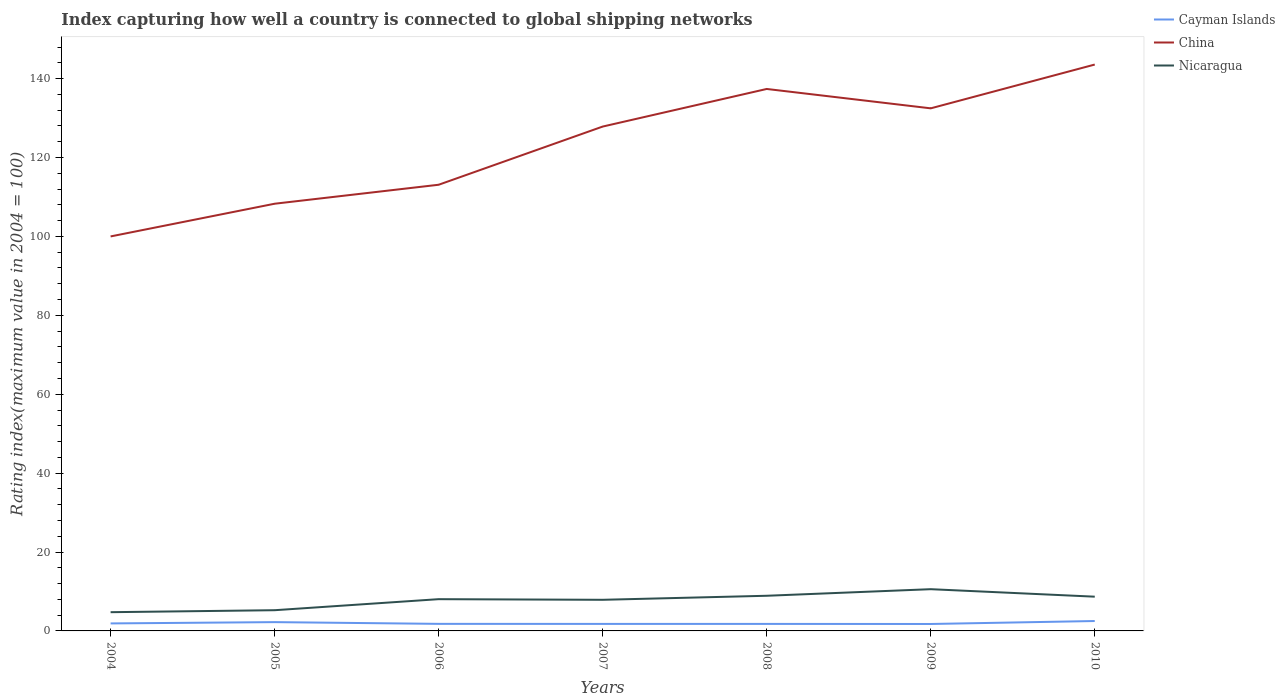Across all years, what is the maximum rating index in Nicaragua?
Keep it short and to the point. 4.75. In which year was the rating index in Nicaragua maximum?
Offer a terse response. 2004. What is the total rating index in China in the graph?
Your answer should be compact. -43.57. What is the difference between the highest and the second highest rating index in Cayman Islands?
Your answer should be very brief. 0.75. What is the difference between the highest and the lowest rating index in Cayman Islands?
Keep it short and to the point. 2. Is the rating index in Cayman Islands strictly greater than the rating index in China over the years?
Ensure brevity in your answer.  Yes. How many years are there in the graph?
Ensure brevity in your answer.  7. Are the values on the major ticks of Y-axis written in scientific E-notation?
Ensure brevity in your answer.  No. Does the graph contain any zero values?
Provide a short and direct response. No. Does the graph contain grids?
Provide a succinct answer. No. How are the legend labels stacked?
Offer a terse response. Vertical. What is the title of the graph?
Your answer should be very brief. Index capturing how well a country is connected to global shipping networks. Does "Solomon Islands" appear as one of the legend labels in the graph?
Your response must be concise. No. What is the label or title of the X-axis?
Your response must be concise. Years. What is the label or title of the Y-axis?
Offer a terse response. Rating index(maximum value in 2004 = 100). What is the Rating index(maximum value in 2004 = 100) in Cayman Islands in 2004?
Ensure brevity in your answer.  1.9. What is the Rating index(maximum value in 2004 = 100) in Nicaragua in 2004?
Your response must be concise. 4.75. What is the Rating index(maximum value in 2004 = 100) in Cayman Islands in 2005?
Provide a succinct answer. 2.23. What is the Rating index(maximum value in 2004 = 100) in China in 2005?
Offer a very short reply. 108.29. What is the Rating index(maximum value in 2004 = 100) in Nicaragua in 2005?
Provide a short and direct response. 5.25. What is the Rating index(maximum value in 2004 = 100) of Cayman Islands in 2006?
Provide a succinct answer. 1.79. What is the Rating index(maximum value in 2004 = 100) in China in 2006?
Ensure brevity in your answer.  113.1. What is the Rating index(maximum value in 2004 = 100) of Nicaragua in 2006?
Your answer should be very brief. 8.05. What is the Rating index(maximum value in 2004 = 100) of Cayman Islands in 2007?
Your response must be concise. 1.78. What is the Rating index(maximum value in 2004 = 100) in China in 2007?
Give a very brief answer. 127.85. What is the Rating index(maximum value in 2004 = 100) in Nicaragua in 2007?
Provide a succinct answer. 7.89. What is the Rating index(maximum value in 2004 = 100) of Cayman Islands in 2008?
Your response must be concise. 1.78. What is the Rating index(maximum value in 2004 = 100) of China in 2008?
Provide a succinct answer. 137.38. What is the Rating index(maximum value in 2004 = 100) of Nicaragua in 2008?
Offer a very short reply. 8.91. What is the Rating index(maximum value in 2004 = 100) of Cayman Islands in 2009?
Keep it short and to the point. 1.76. What is the Rating index(maximum value in 2004 = 100) of China in 2009?
Keep it short and to the point. 132.47. What is the Rating index(maximum value in 2004 = 100) in Nicaragua in 2009?
Provide a succinct answer. 10.58. What is the Rating index(maximum value in 2004 = 100) in Cayman Islands in 2010?
Give a very brief answer. 2.51. What is the Rating index(maximum value in 2004 = 100) of China in 2010?
Your answer should be compact. 143.57. What is the Rating index(maximum value in 2004 = 100) of Nicaragua in 2010?
Your answer should be very brief. 8.68. Across all years, what is the maximum Rating index(maximum value in 2004 = 100) in Cayman Islands?
Provide a succinct answer. 2.51. Across all years, what is the maximum Rating index(maximum value in 2004 = 100) of China?
Make the answer very short. 143.57. Across all years, what is the maximum Rating index(maximum value in 2004 = 100) in Nicaragua?
Keep it short and to the point. 10.58. Across all years, what is the minimum Rating index(maximum value in 2004 = 100) of Cayman Islands?
Make the answer very short. 1.76. Across all years, what is the minimum Rating index(maximum value in 2004 = 100) of China?
Make the answer very short. 100. Across all years, what is the minimum Rating index(maximum value in 2004 = 100) of Nicaragua?
Offer a terse response. 4.75. What is the total Rating index(maximum value in 2004 = 100) in Cayman Islands in the graph?
Give a very brief answer. 13.75. What is the total Rating index(maximum value in 2004 = 100) in China in the graph?
Provide a short and direct response. 862.66. What is the total Rating index(maximum value in 2004 = 100) of Nicaragua in the graph?
Offer a terse response. 54.11. What is the difference between the Rating index(maximum value in 2004 = 100) in Cayman Islands in 2004 and that in 2005?
Your response must be concise. -0.33. What is the difference between the Rating index(maximum value in 2004 = 100) in China in 2004 and that in 2005?
Keep it short and to the point. -8.29. What is the difference between the Rating index(maximum value in 2004 = 100) of Cayman Islands in 2004 and that in 2006?
Provide a succinct answer. 0.11. What is the difference between the Rating index(maximum value in 2004 = 100) of China in 2004 and that in 2006?
Make the answer very short. -13.1. What is the difference between the Rating index(maximum value in 2004 = 100) of Nicaragua in 2004 and that in 2006?
Offer a terse response. -3.3. What is the difference between the Rating index(maximum value in 2004 = 100) in Cayman Islands in 2004 and that in 2007?
Provide a short and direct response. 0.12. What is the difference between the Rating index(maximum value in 2004 = 100) of China in 2004 and that in 2007?
Your answer should be very brief. -27.85. What is the difference between the Rating index(maximum value in 2004 = 100) of Nicaragua in 2004 and that in 2007?
Keep it short and to the point. -3.14. What is the difference between the Rating index(maximum value in 2004 = 100) of Cayman Islands in 2004 and that in 2008?
Your response must be concise. 0.12. What is the difference between the Rating index(maximum value in 2004 = 100) of China in 2004 and that in 2008?
Provide a succinct answer. -37.38. What is the difference between the Rating index(maximum value in 2004 = 100) in Nicaragua in 2004 and that in 2008?
Your response must be concise. -4.16. What is the difference between the Rating index(maximum value in 2004 = 100) in Cayman Islands in 2004 and that in 2009?
Offer a terse response. 0.14. What is the difference between the Rating index(maximum value in 2004 = 100) of China in 2004 and that in 2009?
Your answer should be very brief. -32.47. What is the difference between the Rating index(maximum value in 2004 = 100) of Nicaragua in 2004 and that in 2009?
Make the answer very short. -5.83. What is the difference between the Rating index(maximum value in 2004 = 100) of Cayman Islands in 2004 and that in 2010?
Keep it short and to the point. -0.61. What is the difference between the Rating index(maximum value in 2004 = 100) in China in 2004 and that in 2010?
Offer a terse response. -43.57. What is the difference between the Rating index(maximum value in 2004 = 100) in Nicaragua in 2004 and that in 2010?
Your answer should be compact. -3.93. What is the difference between the Rating index(maximum value in 2004 = 100) in Cayman Islands in 2005 and that in 2006?
Provide a short and direct response. 0.44. What is the difference between the Rating index(maximum value in 2004 = 100) of China in 2005 and that in 2006?
Offer a terse response. -4.81. What is the difference between the Rating index(maximum value in 2004 = 100) of Cayman Islands in 2005 and that in 2007?
Ensure brevity in your answer.  0.45. What is the difference between the Rating index(maximum value in 2004 = 100) in China in 2005 and that in 2007?
Give a very brief answer. -19.56. What is the difference between the Rating index(maximum value in 2004 = 100) in Nicaragua in 2005 and that in 2007?
Keep it short and to the point. -2.64. What is the difference between the Rating index(maximum value in 2004 = 100) in Cayman Islands in 2005 and that in 2008?
Make the answer very short. 0.45. What is the difference between the Rating index(maximum value in 2004 = 100) in China in 2005 and that in 2008?
Your answer should be very brief. -29.09. What is the difference between the Rating index(maximum value in 2004 = 100) in Nicaragua in 2005 and that in 2008?
Keep it short and to the point. -3.66. What is the difference between the Rating index(maximum value in 2004 = 100) of Cayman Islands in 2005 and that in 2009?
Make the answer very short. 0.47. What is the difference between the Rating index(maximum value in 2004 = 100) in China in 2005 and that in 2009?
Your response must be concise. -24.18. What is the difference between the Rating index(maximum value in 2004 = 100) of Nicaragua in 2005 and that in 2009?
Your answer should be compact. -5.33. What is the difference between the Rating index(maximum value in 2004 = 100) in Cayman Islands in 2005 and that in 2010?
Ensure brevity in your answer.  -0.28. What is the difference between the Rating index(maximum value in 2004 = 100) in China in 2005 and that in 2010?
Keep it short and to the point. -35.28. What is the difference between the Rating index(maximum value in 2004 = 100) of Nicaragua in 2005 and that in 2010?
Your answer should be compact. -3.43. What is the difference between the Rating index(maximum value in 2004 = 100) in China in 2006 and that in 2007?
Offer a very short reply. -14.75. What is the difference between the Rating index(maximum value in 2004 = 100) of Nicaragua in 2006 and that in 2007?
Give a very brief answer. 0.16. What is the difference between the Rating index(maximum value in 2004 = 100) in Cayman Islands in 2006 and that in 2008?
Your response must be concise. 0.01. What is the difference between the Rating index(maximum value in 2004 = 100) of China in 2006 and that in 2008?
Give a very brief answer. -24.28. What is the difference between the Rating index(maximum value in 2004 = 100) of Nicaragua in 2006 and that in 2008?
Your response must be concise. -0.86. What is the difference between the Rating index(maximum value in 2004 = 100) of China in 2006 and that in 2009?
Provide a succinct answer. -19.37. What is the difference between the Rating index(maximum value in 2004 = 100) in Nicaragua in 2006 and that in 2009?
Your answer should be compact. -2.53. What is the difference between the Rating index(maximum value in 2004 = 100) of Cayman Islands in 2006 and that in 2010?
Give a very brief answer. -0.72. What is the difference between the Rating index(maximum value in 2004 = 100) in China in 2006 and that in 2010?
Give a very brief answer. -30.47. What is the difference between the Rating index(maximum value in 2004 = 100) in Nicaragua in 2006 and that in 2010?
Provide a succinct answer. -0.63. What is the difference between the Rating index(maximum value in 2004 = 100) in Cayman Islands in 2007 and that in 2008?
Give a very brief answer. 0. What is the difference between the Rating index(maximum value in 2004 = 100) in China in 2007 and that in 2008?
Ensure brevity in your answer.  -9.53. What is the difference between the Rating index(maximum value in 2004 = 100) of Nicaragua in 2007 and that in 2008?
Your response must be concise. -1.02. What is the difference between the Rating index(maximum value in 2004 = 100) in China in 2007 and that in 2009?
Make the answer very short. -4.62. What is the difference between the Rating index(maximum value in 2004 = 100) in Nicaragua in 2007 and that in 2009?
Keep it short and to the point. -2.69. What is the difference between the Rating index(maximum value in 2004 = 100) of Cayman Islands in 2007 and that in 2010?
Your answer should be compact. -0.73. What is the difference between the Rating index(maximum value in 2004 = 100) in China in 2007 and that in 2010?
Ensure brevity in your answer.  -15.72. What is the difference between the Rating index(maximum value in 2004 = 100) of Nicaragua in 2007 and that in 2010?
Ensure brevity in your answer.  -0.79. What is the difference between the Rating index(maximum value in 2004 = 100) in Cayman Islands in 2008 and that in 2009?
Keep it short and to the point. 0.02. What is the difference between the Rating index(maximum value in 2004 = 100) in China in 2008 and that in 2009?
Your answer should be very brief. 4.91. What is the difference between the Rating index(maximum value in 2004 = 100) of Nicaragua in 2008 and that in 2009?
Make the answer very short. -1.67. What is the difference between the Rating index(maximum value in 2004 = 100) in Cayman Islands in 2008 and that in 2010?
Offer a very short reply. -0.73. What is the difference between the Rating index(maximum value in 2004 = 100) in China in 2008 and that in 2010?
Your answer should be compact. -6.19. What is the difference between the Rating index(maximum value in 2004 = 100) in Nicaragua in 2008 and that in 2010?
Your answer should be very brief. 0.23. What is the difference between the Rating index(maximum value in 2004 = 100) in Cayman Islands in 2009 and that in 2010?
Your answer should be compact. -0.75. What is the difference between the Rating index(maximum value in 2004 = 100) of China in 2009 and that in 2010?
Provide a succinct answer. -11.1. What is the difference between the Rating index(maximum value in 2004 = 100) of Nicaragua in 2009 and that in 2010?
Your answer should be compact. 1.9. What is the difference between the Rating index(maximum value in 2004 = 100) of Cayman Islands in 2004 and the Rating index(maximum value in 2004 = 100) of China in 2005?
Provide a short and direct response. -106.39. What is the difference between the Rating index(maximum value in 2004 = 100) in Cayman Islands in 2004 and the Rating index(maximum value in 2004 = 100) in Nicaragua in 2005?
Offer a terse response. -3.35. What is the difference between the Rating index(maximum value in 2004 = 100) of China in 2004 and the Rating index(maximum value in 2004 = 100) of Nicaragua in 2005?
Give a very brief answer. 94.75. What is the difference between the Rating index(maximum value in 2004 = 100) in Cayman Islands in 2004 and the Rating index(maximum value in 2004 = 100) in China in 2006?
Keep it short and to the point. -111.2. What is the difference between the Rating index(maximum value in 2004 = 100) of Cayman Islands in 2004 and the Rating index(maximum value in 2004 = 100) of Nicaragua in 2006?
Provide a succinct answer. -6.15. What is the difference between the Rating index(maximum value in 2004 = 100) of China in 2004 and the Rating index(maximum value in 2004 = 100) of Nicaragua in 2006?
Your response must be concise. 91.95. What is the difference between the Rating index(maximum value in 2004 = 100) in Cayman Islands in 2004 and the Rating index(maximum value in 2004 = 100) in China in 2007?
Offer a very short reply. -125.95. What is the difference between the Rating index(maximum value in 2004 = 100) of Cayman Islands in 2004 and the Rating index(maximum value in 2004 = 100) of Nicaragua in 2007?
Provide a short and direct response. -5.99. What is the difference between the Rating index(maximum value in 2004 = 100) of China in 2004 and the Rating index(maximum value in 2004 = 100) of Nicaragua in 2007?
Keep it short and to the point. 92.11. What is the difference between the Rating index(maximum value in 2004 = 100) of Cayman Islands in 2004 and the Rating index(maximum value in 2004 = 100) of China in 2008?
Keep it short and to the point. -135.48. What is the difference between the Rating index(maximum value in 2004 = 100) of Cayman Islands in 2004 and the Rating index(maximum value in 2004 = 100) of Nicaragua in 2008?
Keep it short and to the point. -7.01. What is the difference between the Rating index(maximum value in 2004 = 100) of China in 2004 and the Rating index(maximum value in 2004 = 100) of Nicaragua in 2008?
Your response must be concise. 91.09. What is the difference between the Rating index(maximum value in 2004 = 100) in Cayman Islands in 2004 and the Rating index(maximum value in 2004 = 100) in China in 2009?
Your answer should be compact. -130.57. What is the difference between the Rating index(maximum value in 2004 = 100) in Cayman Islands in 2004 and the Rating index(maximum value in 2004 = 100) in Nicaragua in 2009?
Your answer should be compact. -8.68. What is the difference between the Rating index(maximum value in 2004 = 100) in China in 2004 and the Rating index(maximum value in 2004 = 100) in Nicaragua in 2009?
Your answer should be very brief. 89.42. What is the difference between the Rating index(maximum value in 2004 = 100) in Cayman Islands in 2004 and the Rating index(maximum value in 2004 = 100) in China in 2010?
Ensure brevity in your answer.  -141.67. What is the difference between the Rating index(maximum value in 2004 = 100) of Cayman Islands in 2004 and the Rating index(maximum value in 2004 = 100) of Nicaragua in 2010?
Give a very brief answer. -6.78. What is the difference between the Rating index(maximum value in 2004 = 100) of China in 2004 and the Rating index(maximum value in 2004 = 100) of Nicaragua in 2010?
Offer a terse response. 91.32. What is the difference between the Rating index(maximum value in 2004 = 100) of Cayman Islands in 2005 and the Rating index(maximum value in 2004 = 100) of China in 2006?
Offer a terse response. -110.87. What is the difference between the Rating index(maximum value in 2004 = 100) of Cayman Islands in 2005 and the Rating index(maximum value in 2004 = 100) of Nicaragua in 2006?
Offer a terse response. -5.82. What is the difference between the Rating index(maximum value in 2004 = 100) of China in 2005 and the Rating index(maximum value in 2004 = 100) of Nicaragua in 2006?
Make the answer very short. 100.24. What is the difference between the Rating index(maximum value in 2004 = 100) in Cayman Islands in 2005 and the Rating index(maximum value in 2004 = 100) in China in 2007?
Offer a terse response. -125.62. What is the difference between the Rating index(maximum value in 2004 = 100) of Cayman Islands in 2005 and the Rating index(maximum value in 2004 = 100) of Nicaragua in 2007?
Ensure brevity in your answer.  -5.66. What is the difference between the Rating index(maximum value in 2004 = 100) in China in 2005 and the Rating index(maximum value in 2004 = 100) in Nicaragua in 2007?
Offer a terse response. 100.4. What is the difference between the Rating index(maximum value in 2004 = 100) in Cayman Islands in 2005 and the Rating index(maximum value in 2004 = 100) in China in 2008?
Your answer should be compact. -135.15. What is the difference between the Rating index(maximum value in 2004 = 100) of Cayman Islands in 2005 and the Rating index(maximum value in 2004 = 100) of Nicaragua in 2008?
Offer a very short reply. -6.68. What is the difference between the Rating index(maximum value in 2004 = 100) of China in 2005 and the Rating index(maximum value in 2004 = 100) of Nicaragua in 2008?
Offer a very short reply. 99.38. What is the difference between the Rating index(maximum value in 2004 = 100) of Cayman Islands in 2005 and the Rating index(maximum value in 2004 = 100) of China in 2009?
Ensure brevity in your answer.  -130.24. What is the difference between the Rating index(maximum value in 2004 = 100) of Cayman Islands in 2005 and the Rating index(maximum value in 2004 = 100) of Nicaragua in 2009?
Give a very brief answer. -8.35. What is the difference between the Rating index(maximum value in 2004 = 100) in China in 2005 and the Rating index(maximum value in 2004 = 100) in Nicaragua in 2009?
Your answer should be compact. 97.71. What is the difference between the Rating index(maximum value in 2004 = 100) in Cayman Islands in 2005 and the Rating index(maximum value in 2004 = 100) in China in 2010?
Make the answer very short. -141.34. What is the difference between the Rating index(maximum value in 2004 = 100) in Cayman Islands in 2005 and the Rating index(maximum value in 2004 = 100) in Nicaragua in 2010?
Your answer should be very brief. -6.45. What is the difference between the Rating index(maximum value in 2004 = 100) in China in 2005 and the Rating index(maximum value in 2004 = 100) in Nicaragua in 2010?
Offer a terse response. 99.61. What is the difference between the Rating index(maximum value in 2004 = 100) in Cayman Islands in 2006 and the Rating index(maximum value in 2004 = 100) in China in 2007?
Provide a short and direct response. -126.06. What is the difference between the Rating index(maximum value in 2004 = 100) of China in 2006 and the Rating index(maximum value in 2004 = 100) of Nicaragua in 2007?
Make the answer very short. 105.21. What is the difference between the Rating index(maximum value in 2004 = 100) of Cayman Islands in 2006 and the Rating index(maximum value in 2004 = 100) of China in 2008?
Make the answer very short. -135.59. What is the difference between the Rating index(maximum value in 2004 = 100) in Cayman Islands in 2006 and the Rating index(maximum value in 2004 = 100) in Nicaragua in 2008?
Give a very brief answer. -7.12. What is the difference between the Rating index(maximum value in 2004 = 100) in China in 2006 and the Rating index(maximum value in 2004 = 100) in Nicaragua in 2008?
Ensure brevity in your answer.  104.19. What is the difference between the Rating index(maximum value in 2004 = 100) in Cayman Islands in 2006 and the Rating index(maximum value in 2004 = 100) in China in 2009?
Offer a terse response. -130.68. What is the difference between the Rating index(maximum value in 2004 = 100) of Cayman Islands in 2006 and the Rating index(maximum value in 2004 = 100) of Nicaragua in 2009?
Offer a terse response. -8.79. What is the difference between the Rating index(maximum value in 2004 = 100) of China in 2006 and the Rating index(maximum value in 2004 = 100) of Nicaragua in 2009?
Give a very brief answer. 102.52. What is the difference between the Rating index(maximum value in 2004 = 100) in Cayman Islands in 2006 and the Rating index(maximum value in 2004 = 100) in China in 2010?
Provide a succinct answer. -141.78. What is the difference between the Rating index(maximum value in 2004 = 100) in Cayman Islands in 2006 and the Rating index(maximum value in 2004 = 100) in Nicaragua in 2010?
Provide a succinct answer. -6.89. What is the difference between the Rating index(maximum value in 2004 = 100) in China in 2006 and the Rating index(maximum value in 2004 = 100) in Nicaragua in 2010?
Offer a very short reply. 104.42. What is the difference between the Rating index(maximum value in 2004 = 100) of Cayman Islands in 2007 and the Rating index(maximum value in 2004 = 100) of China in 2008?
Offer a very short reply. -135.6. What is the difference between the Rating index(maximum value in 2004 = 100) of Cayman Islands in 2007 and the Rating index(maximum value in 2004 = 100) of Nicaragua in 2008?
Make the answer very short. -7.13. What is the difference between the Rating index(maximum value in 2004 = 100) of China in 2007 and the Rating index(maximum value in 2004 = 100) of Nicaragua in 2008?
Your answer should be compact. 118.94. What is the difference between the Rating index(maximum value in 2004 = 100) of Cayman Islands in 2007 and the Rating index(maximum value in 2004 = 100) of China in 2009?
Ensure brevity in your answer.  -130.69. What is the difference between the Rating index(maximum value in 2004 = 100) of Cayman Islands in 2007 and the Rating index(maximum value in 2004 = 100) of Nicaragua in 2009?
Your answer should be compact. -8.8. What is the difference between the Rating index(maximum value in 2004 = 100) of China in 2007 and the Rating index(maximum value in 2004 = 100) of Nicaragua in 2009?
Your answer should be very brief. 117.27. What is the difference between the Rating index(maximum value in 2004 = 100) in Cayman Islands in 2007 and the Rating index(maximum value in 2004 = 100) in China in 2010?
Make the answer very short. -141.79. What is the difference between the Rating index(maximum value in 2004 = 100) of China in 2007 and the Rating index(maximum value in 2004 = 100) of Nicaragua in 2010?
Offer a terse response. 119.17. What is the difference between the Rating index(maximum value in 2004 = 100) in Cayman Islands in 2008 and the Rating index(maximum value in 2004 = 100) in China in 2009?
Give a very brief answer. -130.69. What is the difference between the Rating index(maximum value in 2004 = 100) in Cayman Islands in 2008 and the Rating index(maximum value in 2004 = 100) in Nicaragua in 2009?
Your answer should be compact. -8.8. What is the difference between the Rating index(maximum value in 2004 = 100) in China in 2008 and the Rating index(maximum value in 2004 = 100) in Nicaragua in 2009?
Make the answer very short. 126.8. What is the difference between the Rating index(maximum value in 2004 = 100) in Cayman Islands in 2008 and the Rating index(maximum value in 2004 = 100) in China in 2010?
Ensure brevity in your answer.  -141.79. What is the difference between the Rating index(maximum value in 2004 = 100) of China in 2008 and the Rating index(maximum value in 2004 = 100) of Nicaragua in 2010?
Ensure brevity in your answer.  128.7. What is the difference between the Rating index(maximum value in 2004 = 100) of Cayman Islands in 2009 and the Rating index(maximum value in 2004 = 100) of China in 2010?
Offer a very short reply. -141.81. What is the difference between the Rating index(maximum value in 2004 = 100) of Cayman Islands in 2009 and the Rating index(maximum value in 2004 = 100) of Nicaragua in 2010?
Provide a short and direct response. -6.92. What is the difference between the Rating index(maximum value in 2004 = 100) in China in 2009 and the Rating index(maximum value in 2004 = 100) in Nicaragua in 2010?
Keep it short and to the point. 123.79. What is the average Rating index(maximum value in 2004 = 100) in Cayman Islands per year?
Provide a succinct answer. 1.96. What is the average Rating index(maximum value in 2004 = 100) of China per year?
Offer a very short reply. 123.24. What is the average Rating index(maximum value in 2004 = 100) in Nicaragua per year?
Your response must be concise. 7.73. In the year 2004, what is the difference between the Rating index(maximum value in 2004 = 100) of Cayman Islands and Rating index(maximum value in 2004 = 100) of China?
Provide a succinct answer. -98.1. In the year 2004, what is the difference between the Rating index(maximum value in 2004 = 100) in Cayman Islands and Rating index(maximum value in 2004 = 100) in Nicaragua?
Your answer should be very brief. -2.85. In the year 2004, what is the difference between the Rating index(maximum value in 2004 = 100) in China and Rating index(maximum value in 2004 = 100) in Nicaragua?
Ensure brevity in your answer.  95.25. In the year 2005, what is the difference between the Rating index(maximum value in 2004 = 100) of Cayman Islands and Rating index(maximum value in 2004 = 100) of China?
Provide a succinct answer. -106.06. In the year 2005, what is the difference between the Rating index(maximum value in 2004 = 100) of Cayman Islands and Rating index(maximum value in 2004 = 100) of Nicaragua?
Give a very brief answer. -3.02. In the year 2005, what is the difference between the Rating index(maximum value in 2004 = 100) in China and Rating index(maximum value in 2004 = 100) in Nicaragua?
Offer a very short reply. 103.04. In the year 2006, what is the difference between the Rating index(maximum value in 2004 = 100) in Cayman Islands and Rating index(maximum value in 2004 = 100) in China?
Your response must be concise. -111.31. In the year 2006, what is the difference between the Rating index(maximum value in 2004 = 100) of Cayman Islands and Rating index(maximum value in 2004 = 100) of Nicaragua?
Keep it short and to the point. -6.26. In the year 2006, what is the difference between the Rating index(maximum value in 2004 = 100) of China and Rating index(maximum value in 2004 = 100) of Nicaragua?
Ensure brevity in your answer.  105.05. In the year 2007, what is the difference between the Rating index(maximum value in 2004 = 100) in Cayman Islands and Rating index(maximum value in 2004 = 100) in China?
Provide a short and direct response. -126.07. In the year 2007, what is the difference between the Rating index(maximum value in 2004 = 100) in Cayman Islands and Rating index(maximum value in 2004 = 100) in Nicaragua?
Keep it short and to the point. -6.11. In the year 2007, what is the difference between the Rating index(maximum value in 2004 = 100) of China and Rating index(maximum value in 2004 = 100) of Nicaragua?
Offer a terse response. 119.96. In the year 2008, what is the difference between the Rating index(maximum value in 2004 = 100) in Cayman Islands and Rating index(maximum value in 2004 = 100) in China?
Give a very brief answer. -135.6. In the year 2008, what is the difference between the Rating index(maximum value in 2004 = 100) of Cayman Islands and Rating index(maximum value in 2004 = 100) of Nicaragua?
Your answer should be compact. -7.13. In the year 2008, what is the difference between the Rating index(maximum value in 2004 = 100) in China and Rating index(maximum value in 2004 = 100) in Nicaragua?
Offer a terse response. 128.47. In the year 2009, what is the difference between the Rating index(maximum value in 2004 = 100) of Cayman Islands and Rating index(maximum value in 2004 = 100) of China?
Give a very brief answer. -130.71. In the year 2009, what is the difference between the Rating index(maximum value in 2004 = 100) in Cayman Islands and Rating index(maximum value in 2004 = 100) in Nicaragua?
Your answer should be compact. -8.82. In the year 2009, what is the difference between the Rating index(maximum value in 2004 = 100) in China and Rating index(maximum value in 2004 = 100) in Nicaragua?
Your answer should be very brief. 121.89. In the year 2010, what is the difference between the Rating index(maximum value in 2004 = 100) of Cayman Islands and Rating index(maximum value in 2004 = 100) of China?
Make the answer very short. -141.06. In the year 2010, what is the difference between the Rating index(maximum value in 2004 = 100) in Cayman Islands and Rating index(maximum value in 2004 = 100) in Nicaragua?
Provide a succinct answer. -6.17. In the year 2010, what is the difference between the Rating index(maximum value in 2004 = 100) in China and Rating index(maximum value in 2004 = 100) in Nicaragua?
Ensure brevity in your answer.  134.89. What is the ratio of the Rating index(maximum value in 2004 = 100) in Cayman Islands in 2004 to that in 2005?
Your answer should be compact. 0.85. What is the ratio of the Rating index(maximum value in 2004 = 100) of China in 2004 to that in 2005?
Provide a short and direct response. 0.92. What is the ratio of the Rating index(maximum value in 2004 = 100) in Nicaragua in 2004 to that in 2005?
Ensure brevity in your answer.  0.9. What is the ratio of the Rating index(maximum value in 2004 = 100) in Cayman Islands in 2004 to that in 2006?
Give a very brief answer. 1.06. What is the ratio of the Rating index(maximum value in 2004 = 100) in China in 2004 to that in 2006?
Provide a succinct answer. 0.88. What is the ratio of the Rating index(maximum value in 2004 = 100) of Nicaragua in 2004 to that in 2006?
Your response must be concise. 0.59. What is the ratio of the Rating index(maximum value in 2004 = 100) in Cayman Islands in 2004 to that in 2007?
Give a very brief answer. 1.07. What is the ratio of the Rating index(maximum value in 2004 = 100) in China in 2004 to that in 2007?
Offer a terse response. 0.78. What is the ratio of the Rating index(maximum value in 2004 = 100) of Nicaragua in 2004 to that in 2007?
Ensure brevity in your answer.  0.6. What is the ratio of the Rating index(maximum value in 2004 = 100) of Cayman Islands in 2004 to that in 2008?
Your answer should be compact. 1.07. What is the ratio of the Rating index(maximum value in 2004 = 100) in China in 2004 to that in 2008?
Your answer should be very brief. 0.73. What is the ratio of the Rating index(maximum value in 2004 = 100) of Nicaragua in 2004 to that in 2008?
Give a very brief answer. 0.53. What is the ratio of the Rating index(maximum value in 2004 = 100) in Cayman Islands in 2004 to that in 2009?
Offer a very short reply. 1.08. What is the ratio of the Rating index(maximum value in 2004 = 100) of China in 2004 to that in 2009?
Provide a succinct answer. 0.75. What is the ratio of the Rating index(maximum value in 2004 = 100) in Nicaragua in 2004 to that in 2009?
Offer a terse response. 0.45. What is the ratio of the Rating index(maximum value in 2004 = 100) in Cayman Islands in 2004 to that in 2010?
Your answer should be compact. 0.76. What is the ratio of the Rating index(maximum value in 2004 = 100) in China in 2004 to that in 2010?
Provide a succinct answer. 0.7. What is the ratio of the Rating index(maximum value in 2004 = 100) of Nicaragua in 2004 to that in 2010?
Offer a terse response. 0.55. What is the ratio of the Rating index(maximum value in 2004 = 100) in Cayman Islands in 2005 to that in 2006?
Your answer should be compact. 1.25. What is the ratio of the Rating index(maximum value in 2004 = 100) of China in 2005 to that in 2006?
Offer a terse response. 0.96. What is the ratio of the Rating index(maximum value in 2004 = 100) in Nicaragua in 2005 to that in 2006?
Your response must be concise. 0.65. What is the ratio of the Rating index(maximum value in 2004 = 100) of Cayman Islands in 2005 to that in 2007?
Your answer should be compact. 1.25. What is the ratio of the Rating index(maximum value in 2004 = 100) of China in 2005 to that in 2007?
Offer a terse response. 0.85. What is the ratio of the Rating index(maximum value in 2004 = 100) in Nicaragua in 2005 to that in 2007?
Ensure brevity in your answer.  0.67. What is the ratio of the Rating index(maximum value in 2004 = 100) of Cayman Islands in 2005 to that in 2008?
Keep it short and to the point. 1.25. What is the ratio of the Rating index(maximum value in 2004 = 100) in China in 2005 to that in 2008?
Make the answer very short. 0.79. What is the ratio of the Rating index(maximum value in 2004 = 100) of Nicaragua in 2005 to that in 2008?
Offer a terse response. 0.59. What is the ratio of the Rating index(maximum value in 2004 = 100) in Cayman Islands in 2005 to that in 2009?
Offer a very short reply. 1.27. What is the ratio of the Rating index(maximum value in 2004 = 100) in China in 2005 to that in 2009?
Ensure brevity in your answer.  0.82. What is the ratio of the Rating index(maximum value in 2004 = 100) of Nicaragua in 2005 to that in 2009?
Provide a succinct answer. 0.5. What is the ratio of the Rating index(maximum value in 2004 = 100) of Cayman Islands in 2005 to that in 2010?
Offer a terse response. 0.89. What is the ratio of the Rating index(maximum value in 2004 = 100) in China in 2005 to that in 2010?
Offer a terse response. 0.75. What is the ratio of the Rating index(maximum value in 2004 = 100) of Nicaragua in 2005 to that in 2010?
Offer a terse response. 0.6. What is the ratio of the Rating index(maximum value in 2004 = 100) of Cayman Islands in 2006 to that in 2007?
Offer a terse response. 1.01. What is the ratio of the Rating index(maximum value in 2004 = 100) of China in 2006 to that in 2007?
Offer a very short reply. 0.88. What is the ratio of the Rating index(maximum value in 2004 = 100) in Nicaragua in 2006 to that in 2007?
Provide a succinct answer. 1.02. What is the ratio of the Rating index(maximum value in 2004 = 100) in Cayman Islands in 2006 to that in 2008?
Your response must be concise. 1.01. What is the ratio of the Rating index(maximum value in 2004 = 100) in China in 2006 to that in 2008?
Ensure brevity in your answer.  0.82. What is the ratio of the Rating index(maximum value in 2004 = 100) of Nicaragua in 2006 to that in 2008?
Ensure brevity in your answer.  0.9. What is the ratio of the Rating index(maximum value in 2004 = 100) in China in 2006 to that in 2009?
Provide a short and direct response. 0.85. What is the ratio of the Rating index(maximum value in 2004 = 100) in Nicaragua in 2006 to that in 2009?
Ensure brevity in your answer.  0.76. What is the ratio of the Rating index(maximum value in 2004 = 100) of Cayman Islands in 2006 to that in 2010?
Your answer should be compact. 0.71. What is the ratio of the Rating index(maximum value in 2004 = 100) in China in 2006 to that in 2010?
Your response must be concise. 0.79. What is the ratio of the Rating index(maximum value in 2004 = 100) of Nicaragua in 2006 to that in 2010?
Make the answer very short. 0.93. What is the ratio of the Rating index(maximum value in 2004 = 100) of Cayman Islands in 2007 to that in 2008?
Provide a succinct answer. 1. What is the ratio of the Rating index(maximum value in 2004 = 100) in China in 2007 to that in 2008?
Make the answer very short. 0.93. What is the ratio of the Rating index(maximum value in 2004 = 100) in Nicaragua in 2007 to that in 2008?
Your answer should be compact. 0.89. What is the ratio of the Rating index(maximum value in 2004 = 100) in Cayman Islands in 2007 to that in 2009?
Your answer should be very brief. 1.01. What is the ratio of the Rating index(maximum value in 2004 = 100) of China in 2007 to that in 2009?
Give a very brief answer. 0.97. What is the ratio of the Rating index(maximum value in 2004 = 100) in Nicaragua in 2007 to that in 2009?
Keep it short and to the point. 0.75. What is the ratio of the Rating index(maximum value in 2004 = 100) in Cayman Islands in 2007 to that in 2010?
Provide a succinct answer. 0.71. What is the ratio of the Rating index(maximum value in 2004 = 100) in China in 2007 to that in 2010?
Offer a terse response. 0.89. What is the ratio of the Rating index(maximum value in 2004 = 100) in Nicaragua in 2007 to that in 2010?
Provide a short and direct response. 0.91. What is the ratio of the Rating index(maximum value in 2004 = 100) in Cayman Islands in 2008 to that in 2009?
Your answer should be compact. 1.01. What is the ratio of the Rating index(maximum value in 2004 = 100) in China in 2008 to that in 2009?
Your answer should be compact. 1.04. What is the ratio of the Rating index(maximum value in 2004 = 100) in Nicaragua in 2008 to that in 2009?
Offer a terse response. 0.84. What is the ratio of the Rating index(maximum value in 2004 = 100) in Cayman Islands in 2008 to that in 2010?
Give a very brief answer. 0.71. What is the ratio of the Rating index(maximum value in 2004 = 100) of China in 2008 to that in 2010?
Your answer should be compact. 0.96. What is the ratio of the Rating index(maximum value in 2004 = 100) in Nicaragua in 2008 to that in 2010?
Your response must be concise. 1.03. What is the ratio of the Rating index(maximum value in 2004 = 100) in Cayman Islands in 2009 to that in 2010?
Your answer should be compact. 0.7. What is the ratio of the Rating index(maximum value in 2004 = 100) in China in 2009 to that in 2010?
Ensure brevity in your answer.  0.92. What is the ratio of the Rating index(maximum value in 2004 = 100) in Nicaragua in 2009 to that in 2010?
Offer a very short reply. 1.22. What is the difference between the highest and the second highest Rating index(maximum value in 2004 = 100) in Cayman Islands?
Offer a very short reply. 0.28. What is the difference between the highest and the second highest Rating index(maximum value in 2004 = 100) in China?
Make the answer very short. 6.19. What is the difference between the highest and the second highest Rating index(maximum value in 2004 = 100) of Nicaragua?
Make the answer very short. 1.67. What is the difference between the highest and the lowest Rating index(maximum value in 2004 = 100) in China?
Offer a terse response. 43.57. What is the difference between the highest and the lowest Rating index(maximum value in 2004 = 100) in Nicaragua?
Your response must be concise. 5.83. 